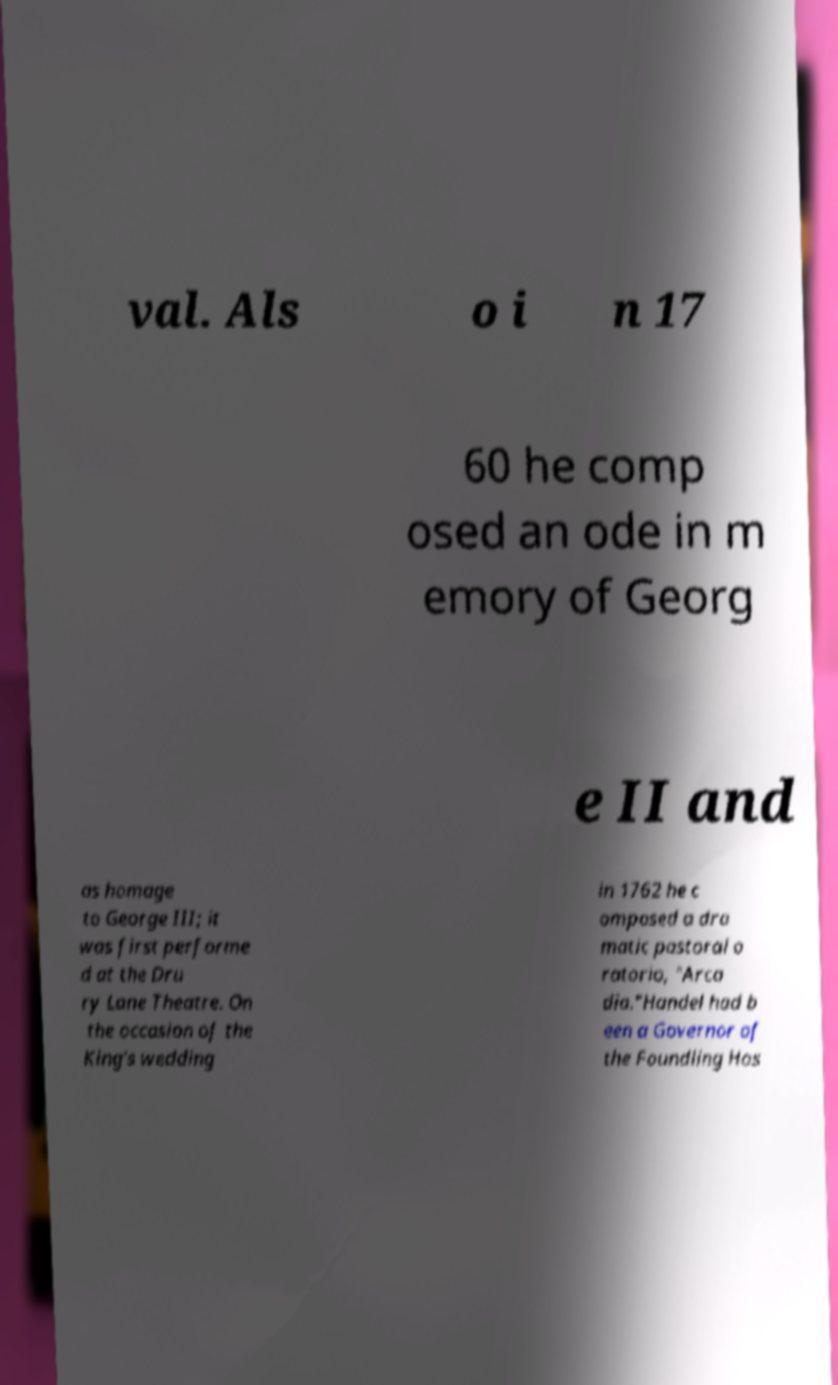Please read and relay the text visible in this image. What does it say? val. Als o i n 17 60 he comp osed an ode in m emory of Georg e II and as homage to George III; it was first performe d at the Dru ry Lane Theatre. On the occasion of the King's wedding in 1762 he c omposed a dra matic pastoral o ratorio, "Arca dia."Handel had b een a Governor of the Foundling Hos 